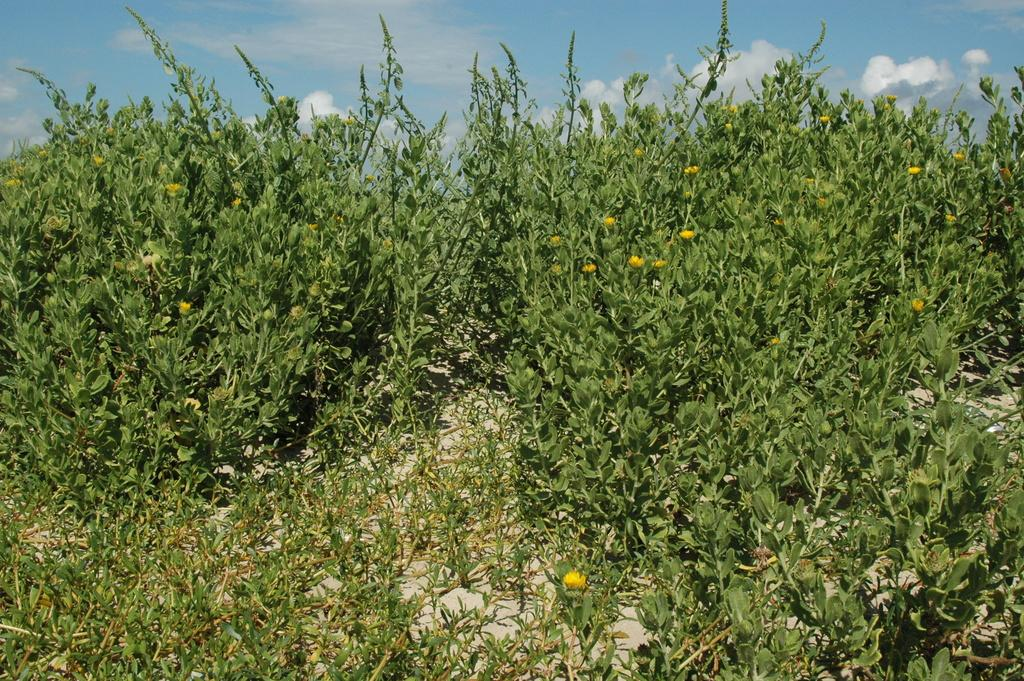What types of living organisms can be seen in the image? Plants and flowers are visible in the image. Can you describe the sky in the image? Clouds are visible in the image. What type of egg can be seen in the image? There is no egg present in the image. Can you describe the airplane flying through the clouds in the image? There is no airplane present in the image; only plants, flowers, and clouds are visible. 